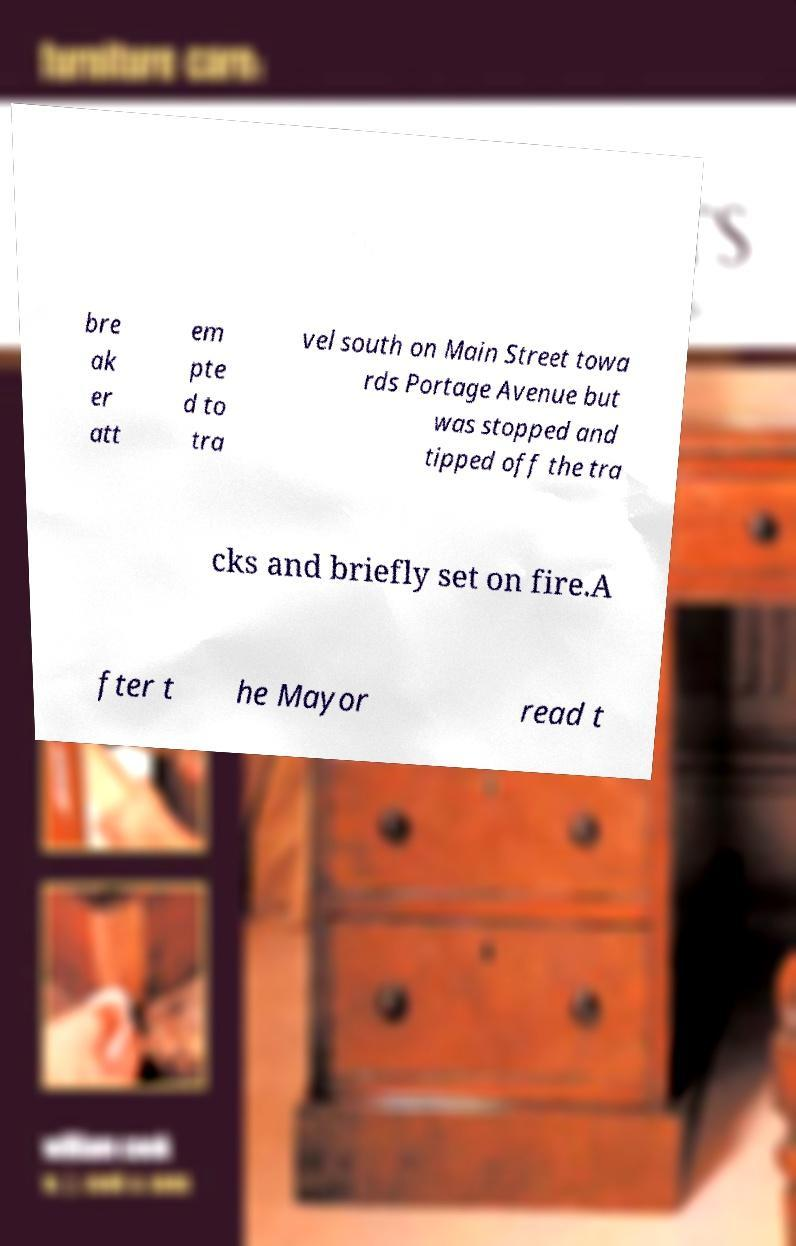Could you assist in decoding the text presented in this image and type it out clearly? bre ak er att em pte d to tra vel south on Main Street towa rds Portage Avenue but was stopped and tipped off the tra cks and briefly set on fire.A fter t he Mayor read t 